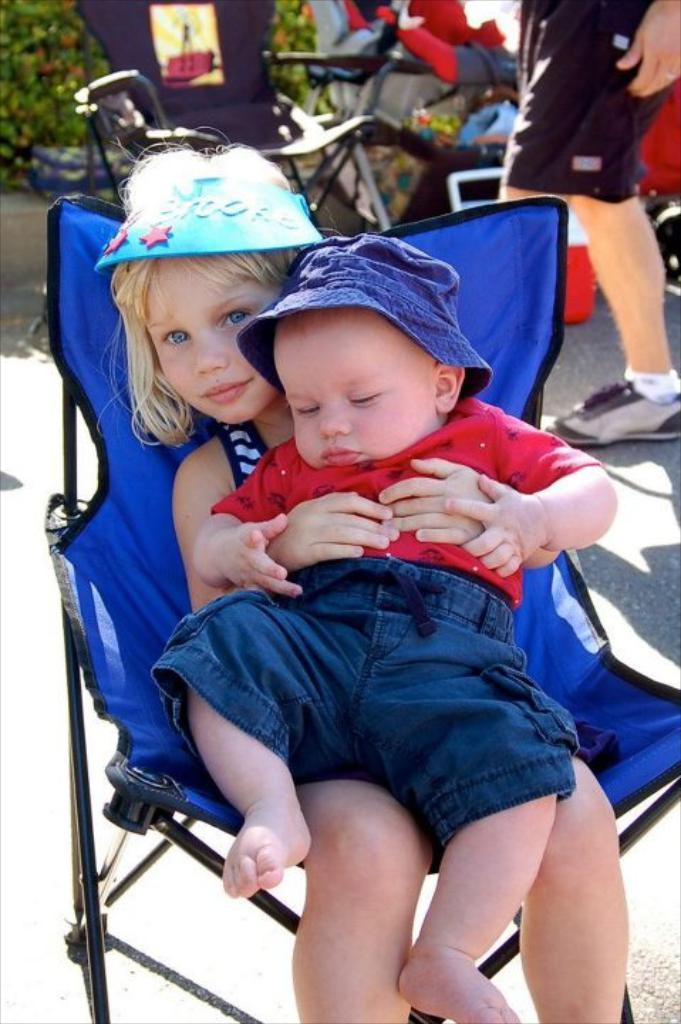What is the girl in the image doing? The girl is sitting on a chair and holding a baby. Can you describe the background of the image? There is a person, another chair, plants, and objects in the background of the image. How many chairs are visible in the image? There are two chairs visible in the image. What type of reward is the girl receiving for her work in the industry? There is no indication in the image that the girl is working in an industry or receiving a reward for her work. 